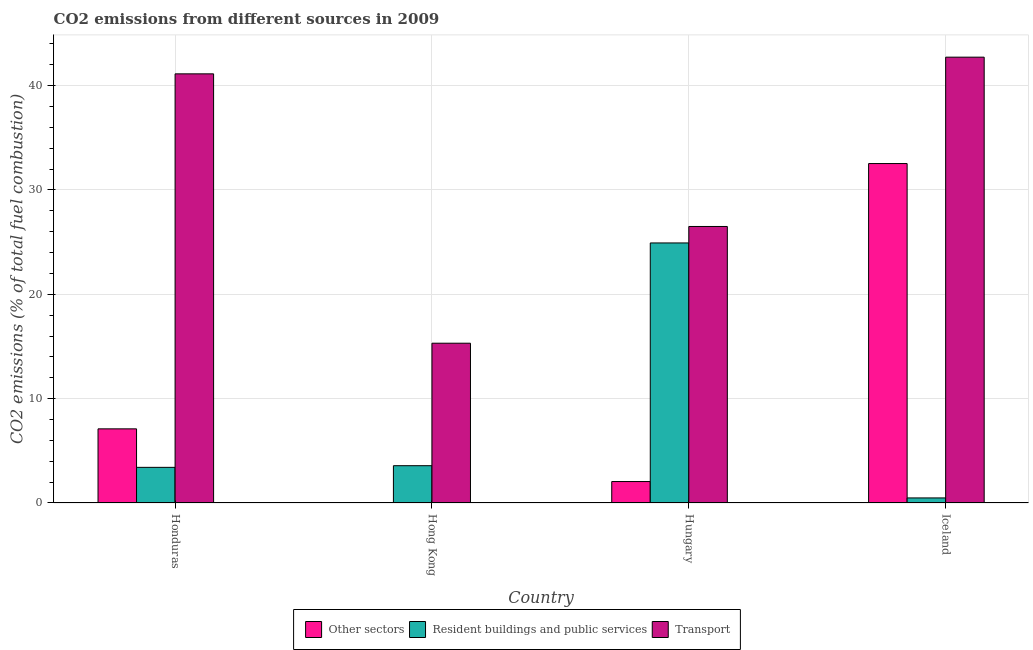How many groups of bars are there?
Make the answer very short. 4. What is the percentage of co2 emissions from resident buildings and public services in Hungary?
Your answer should be very brief. 24.92. Across all countries, what is the maximum percentage of co2 emissions from resident buildings and public services?
Your answer should be compact. 24.92. Across all countries, what is the minimum percentage of co2 emissions from resident buildings and public services?
Provide a succinct answer. 0.49. In which country was the percentage of co2 emissions from other sectors maximum?
Make the answer very short. Iceland. In which country was the percentage of co2 emissions from other sectors minimum?
Keep it short and to the point. Hong Kong. What is the total percentage of co2 emissions from transport in the graph?
Offer a very short reply. 125.64. What is the difference between the percentage of co2 emissions from other sectors in Hong Kong and that in Hungary?
Keep it short and to the point. -2.03. What is the difference between the percentage of co2 emissions from transport in Honduras and the percentage of co2 emissions from resident buildings and public services in Hong Kong?
Your answer should be compact. 37.55. What is the average percentage of co2 emissions from resident buildings and public services per country?
Your response must be concise. 8.1. What is the difference between the percentage of co2 emissions from other sectors and percentage of co2 emissions from resident buildings and public services in Honduras?
Your answer should be very brief. 3.69. What is the ratio of the percentage of co2 emissions from other sectors in Honduras to that in Hungary?
Your response must be concise. 3.46. What is the difference between the highest and the second highest percentage of co2 emissions from resident buildings and public services?
Give a very brief answer. 21.34. What is the difference between the highest and the lowest percentage of co2 emissions from resident buildings and public services?
Keep it short and to the point. 24.43. What does the 1st bar from the left in Honduras represents?
Give a very brief answer. Other sectors. What does the 1st bar from the right in Iceland represents?
Your response must be concise. Transport. How many bars are there?
Make the answer very short. 12. What is the difference between two consecutive major ticks on the Y-axis?
Give a very brief answer. 10. Where does the legend appear in the graph?
Your response must be concise. Bottom center. How are the legend labels stacked?
Give a very brief answer. Horizontal. What is the title of the graph?
Provide a short and direct response. CO2 emissions from different sources in 2009. What is the label or title of the Y-axis?
Your answer should be very brief. CO2 emissions (% of total fuel combustion). What is the CO2 emissions (% of total fuel combustion) in Other sectors in Honduras?
Provide a short and direct response. 7.1. What is the CO2 emissions (% of total fuel combustion) of Resident buildings and public services in Honduras?
Make the answer very short. 3.42. What is the CO2 emissions (% of total fuel combustion) of Transport in Honduras?
Provide a succinct answer. 41.12. What is the CO2 emissions (% of total fuel combustion) of Other sectors in Hong Kong?
Your answer should be very brief. 0.02. What is the CO2 emissions (% of total fuel combustion) in Resident buildings and public services in Hong Kong?
Your response must be concise. 3.57. What is the CO2 emissions (% of total fuel combustion) of Transport in Hong Kong?
Your answer should be compact. 15.31. What is the CO2 emissions (% of total fuel combustion) of Other sectors in Hungary?
Provide a short and direct response. 2.06. What is the CO2 emissions (% of total fuel combustion) in Resident buildings and public services in Hungary?
Your response must be concise. 24.92. What is the CO2 emissions (% of total fuel combustion) of Transport in Hungary?
Your answer should be compact. 26.5. What is the CO2 emissions (% of total fuel combustion) of Other sectors in Iceland?
Keep it short and to the point. 32.52. What is the CO2 emissions (% of total fuel combustion) of Resident buildings and public services in Iceland?
Offer a terse response. 0.49. What is the CO2 emissions (% of total fuel combustion) of Transport in Iceland?
Your answer should be very brief. 42.72. Across all countries, what is the maximum CO2 emissions (% of total fuel combustion) of Other sectors?
Provide a short and direct response. 32.52. Across all countries, what is the maximum CO2 emissions (% of total fuel combustion) of Resident buildings and public services?
Offer a terse response. 24.92. Across all countries, what is the maximum CO2 emissions (% of total fuel combustion) of Transport?
Your answer should be compact. 42.72. Across all countries, what is the minimum CO2 emissions (% of total fuel combustion) of Other sectors?
Keep it short and to the point. 0.02. Across all countries, what is the minimum CO2 emissions (% of total fuel combustion) in Resident buildings and public services?
Offer a very short reply. 0.49. Across all countries, what is the minimum CO2 emissions (% of total fuel combustion) of Transport?
Provide a succinct answer. 15.31. What is the total CO2 emissions (% of total fuel combustion) in Other sectors in the graph?
Make the answer very short. 41.71. What is the total CO2 emissions (% of total fuel combustion) of Resident buildings and public services in the graph?
Your answer should be compact. 32.39. What is the total CO2 emissions (% of total fuel combustion) of Transport in the graph?
Keep it short and to the point. 125.64. What is the difference between the CO2 emissions (% of total fuel combustion) of Other sectors in Honduras and that in Hong Kong?
Ensure brevity in your answer.  7.08. What is the difference between the CO2 emissions (% of total fuel combustion) of Resident buildings and public services in Honduras and that in Hong Kong?
Your answer should be very brief. -0.16. What is the difference between the CO2 emissions (% of total fuel combustion) in Transport in Honduras and that in Hong Kong?
Provide a succinct answer. 25.81. What is the difference between the CO2 emissions (% of total fuel combustion) in Other sectors in Honduras and that in Hungary?
Your response must be concise. 5.05. What is the difference between the CO2 emissions (% of total fuel combustion) in Resident buildings and public services in Honduras and that in Hungary?
Your response must be concise. -21.5. What is the difference between the CO2 emissions (% of total fuel combustion) in Transport in Honduras and that in Hungary?
Keep it short and to the point. 14.63. What is the difference between the CO2 emissions (% of total fuel combustion) in Other sectors in Honduras and that in Iceland?
Your answer should be compact. -25.42. What is the difference between the CO2 emissions (% of total fuel combustion) in Resident buildings and public services in Honduras and that in Iceland?
Offer a very short reply. 2.93. What is the difference between the CO2 emissions (% of total fuel combustion) of Transport in Honduras and that in Iceland?
Your answer should be compact. -1.6. What is the difference between the CO2 emissions (% of total fuel combustion) of Other sectors in Hong Kong and that in Hungary?
Provide a succinct answer. -2.03. What is the difference between the CO2 emissions (% of total fuel combustion) of Resident buildings and public services in Hong Kong and that in Hungary?
Your answer should be compact. -21.34. What is the difference between the CO2 emissions (% of total fuel combustion) in Transport in Hong Kong and that in Hungary?
Provide a succinct answer. -11.19. What is the difference between the CO2 emissions (% of total fuel combustion) of Other sectors in Hong Kong and that in Iceland?
Your response must be concise. -32.5. What is the difference between the CO2 emissions (% of total fuel combustion) in Resident buildings and public services in Hong Kong and that in Iceland?
Offer a very short reply. 3.09. What is the difference between the CO2 emissions (% of total fuel combustion) in Transport in Hong Kong and that in Iceland?
Make the answer very short. -27.41. What is the difference between the CO2 emissions (% of total fuel combustion) of Other sectors in Hungary and that in Iceland?
Your answer should be compact. -30.47. What is the difference between the CO2 emissions (% of total fuel combustion) in Resident buildings and public services in Hungary and that in Iceland?
Offer a terse response. 24.43. What is the difference between the CO2 emissions (% of total fuel combustion) of Transport in Hungary and that in Iceland?
Ensure brevity in your answer.  -16.22. What is the difference between the CO2 emissions (% of total fuel combustion) in Other sectors in Honduras and the CO2 emissions (% of total fuel combustion) in Resident buildings and public services in Hong Kong?
Provide a succinct answer. 3.53. What is the difference between the CO2 emissions (% of total fuel combustion) in Other sectors in Honduras and the CO2 emissions (% of total fuel combustion) in Transport in Hong Kong?
Keep it short and to the point. -8.21. What is the difference between the CO2 emissions (% of total fuel combustion) of Resident buildings and public services in Honduras and the CO2 emissions (% of total fuel combustion) of Transport in Hong Kong?
Offer a terse response. -11.89. What is the difference between the CO2 emissions (% of total fuel combustion) in Other sectors in Honduras and the CO2 emissions (% of total fuel combustion) in Resident buildings and public services in Hungary?
Your response must be concise. -17.81. What is the difference between the CO2 emissions (% of total fuel combustion) of Other sectors in Honduras and the CO2 emissions (% of total fuel combustion) of Transport in Hungary?
Make the answer very short. -19.39. What is the difference between the CO2 emissions (% of total fuel combustion) of Resident buildings and public services in Honduras and the CO2 emissions (% of total fuel combustion) of Transport in Hungary?
Your answer should be very brief. -23.08. What is the difference between the CO2 emissions (% of total fuel combustion) in Other sectors in Honduras and the CO2 emissions (% of total fuel combustion) in Resident buildings and public services in Iceland?
Provide a succinct answer. 6.62. What is the difference between the CO2 emissions (% of total fuel combustion) in Other sectors in Honduras and the CO2 emissions (% of total fuel combustion) in Transport in Iceland?
Offer a very short reply. -35.61. What is the difference between the CO2 emissions (% of total fuel combustion) in Resident buildings and public services in Honduras and the CO2 emissions (% of total fuel combustion) in Transport in Iceland?
Your answer should be compact. -39.3. What is the difference between the CO2 emissions (% of total fuel combustion) of Other sectors in Hong Kong and the CO2 emissions (% of total fuel combustion) of Resident buildings and public services in Hungary?
Ensure brevity in your answer.  -24.9. What is the difference between the CO2 emissions (% of total fuel combustion) in Other sectors in Hong Kong and the CO2 emissions (% of total fuel combustion) in Transport in Hungary?
Your answer should be compact. -26.47. What is the difference between the CO2 emissions (% of total fuel combustion) of Resident buildings and public services in Hong Kong and the CO2 emissions (% of total fuel combustion) of Transport in Hungary?
Offer a very short reply. -22.92. What is the difference between the CO2 emissions (% of total fuel combustion) of Other sectors in Hong Kong and the CO2 emissions (% of total fuel combustion) of Resident buildings and public services in Iceland?
Offer a very short reply. -0.46. What is the difference between the CO2 emissions (% of total fuel combustion) in Other sectors in Hong Kong and the CO2 emissions (% of total fuel combustion) in Transport in Iceland?
Your response must be concise. -42.7. What is the difference between the CO2 emissions (% of total fuel combustion) in Resident buildings and public services in Hong Kong and the CO2 emissions (% of total fuel combustion) in Transport in Iceland?
Your response must be concise. -39.15. What is the difference between the CO2 emissions (% of total fuel combustion) of Other sectors in Hungary and the CO2 emissions (% of total fuel combustion) of Resident buildings and public services in Iceland?
Offer a very short reply. 1.57. What is the difference between the CO2 emissions (% of total fuel combustion) in Other sectors in Hungary and the CO2 emissions (% of total fuel combustion) in Transport in Iceland?
Offer a terse response. -40.66. What is the difference between the CO2 emissions (% of total fuel combustion) of Resident buildings and public services in Hungary and the CO2 emissions (% of total fuel combustion) of Transport in Iceland?
Give a very brief answer. -17.8. What is the average CO2 emissions (% of total fuel combustion) in Other sectors per country?
Your response must be concise. 10.43. What is the average CO2 emissions (% of total fuel combustion) in Resident buildings and public services per country?
Make the answer very short. 8.1. What is the average CO2 emissions (% of total fuel combustion) in Transport per country?
Provide a succinct answer. 31.41. What is the difference between the CO2 emissions (% of total fuel combustion) in Other sectors and CO2 emissions (% of total fuel combustion) in Resident buildings and public services in Honduras?
Your answer should be compact. 3.69. What is the difference between the CO2 emissions (% of total fuel combustion) in Other sectors and CO2 emissions (% of total fuel combustion) in Transport in Honduras?
Offer a terse response. -34.02. What is the difference between the CO2 emissions (% of total fuel combustion) in Resident buildings and public services and CO2 emissions (% of total fuel combustion) in Transport in Honduras?
Your answer should be very brief. -37.7. What is the difference between the CO2 emissions (% of total fuel combustion) of Other sectors and CO2 emissions (% of total fuel combustion) of Resident buildings and public services in Hong Kong?
Offer a very short reply. -3.55. What is the difference between the CO2 emissions (% of total fuel combustion) in Other sectors and CO2 emissions (% of total fuel combustion) in Transport in Hong Kong?
Your response must be concise. -15.29. What is the difference between the CO2 emissions (% of total fuel combustion) of Resident buildings and public services and CO2 emissions (% of total fuel combustion) of Transport in Hong Kong?
Offer a terse response. -11.74. What is the difference between the CO2 emissions (% of total fuel combustion) of Other sectors and CO2 emissions (% of total fuel combustion) of Resident buildings and public services in Hungary?
Ensure brevity in your answer.  -22.86. What is the difference between the CO2 emissions (% of total fuel combustion) in Other sectors and CO2 emissions (% of total fuel combustion) in Transport in Hungary?
Keep it short and to the point. -24.44. What is the difference between the CO2 emissions (% of total fuel combustion) of Resident buildings and public services and CO2 emissions (% of total fuel combustion) of Transport in Hungary?
Give a very brief answer. -1.58. What is the difference between the CO2 emissions (% of total fuel combustion) in Other sectors and CO2 emissions (% of total fuel combustion) in Resident buildings and public services in Iceland?
Ensure brevity in your answer.  32.04. What is the difference between the CO2 emissions (% of total fuel combustion) of Other sectors and CO2 emissions (% of total fuel combustion) of Transport in Iceland?
Give a very brief answer. -10.19. What is the difference between the CO2 emissions (% of total fuel combustion) of Resident buildings and public services and CO2 emissions (% of total fuel combustion) of Transport in Iceland?
Provide a succinct answer. -42.23. What is the ratio of the CO2 emissions (% of total fuel combustion) of Other sectors in Honduras to that in Hong Kong?
Give a very brief answer. 328.05. What is the ratio of the CO2 emissions (% of total fuel combustion) in Resident buildings and public services in Honduras to that in Hong Kong?
Your answer should be compact. 0.96. What is the ratio of the CO2 emissions (% of total fuel combustion) in Transport in Honduras to that in Hong Kong?
Give a very brief answer. 2.69. What is the ratio of the CO2 emissions (% of total fuel combustion) of Other sectors in Honduras to that in Hungary?
Your answer should be compact. 3.46. What is the ratio of the CO2 emissions (% of total fuel combustion) in Resident buildings and public services in Honduras to that in Hungary?
Offer a very short reply. 0.14. What is the ratio of the CO2 emissions (% of total fuel combustion) of Transport in Honduras to that in Hungary?
Provide a succinct answer. 1.55. What is the ratio of the CO2 emissions (% of total fuel combustion) of Other sectors in Honduras to that in Iceland?
Your response must be concise. 0.22. What is the ratio of the CO2 emissions (% of total fuel combustion) of Resident buildings and public services in Honduras to that in Iceland?
Your response must be concise. 7.04. What is the ratio of the CO2 emissions (% of total fuel combustion) of Transport in Honduras to that in Iceland?
Keep it short and to the point. 0.96. What is the ratio of the CO2 emissions (% of total fuel combustion) of Other sectors in Hong Kong to that in Hungary?
Provide a short and direct response. 0.01. What is the ratio of the CO2 emissions (% of total fuel combustion) of Resident buildings and public services in Hong Kong to that in Hungary?
Provide a succinct answer. 0.14. What is the ratio of the CO2 emissions (% of total fuel combustion) of Transport in Hong Kong to that in Hungary?
Ensure brevity in your answer.  0.58. What is the ratio of the CO2 emissions (% of total fuel combustion) in Other sectors in Hong Kong to that in Iceland?
Offer a very short reply. 0. What is the ratio of the CO2 emissions (% of total fuel combustion) in Resident buildings and public services in Hong Kong to that in Iceland?
Your response must be concise. 7.36. What is the ratio of the CO2 emissions (% of total fuel combustion) of Transport in Hong Kong to that in Iceland?
Your answer should be compact. 0.36. What is the ratio of the CO2 emissions (% of total fuel combustion) in Other sectors in Hungary to that in Iceland?
Your answer should be very brief. 0.06. What is the ratio of the CO2 emissions (% of total fuel combustion) of Resident buildings and public services in Hungary to that in Iceland?
Your answer should be compact. 51.33. What is the ratio of the CO2 emissions (% of total fuel combustion) of Transport in Hungary to that in Iceland?
Your answer should be very brief. 0.62. What is the difference between the highest and the second highest CO2 emissions (% of total fuel combustion) in Other sectors?
Keep it short and to the point. 25.42. What is the difference between the highest and the second highest CO2 emissions (% of total fuel combustion) of Resident buildings and public services?
Make the answer very short. 21.34. What is the difference between the highest and the second highest CO2 emissions (% of total fuel combustion) of Transport?
Your response must be concise. 1.6. What is the difference between the highest and the lowest CO2 emissions (% of total fuel combustion) in Other sectors?
Provide a succinct answer. 32.5. What is the difference between the highest and the lowest CO2 emissions (% of total fuel combustion) of Resident buildings and public services?
Make the answer very short. 24.43. What is the difference between the highest and the lowest CO2 emissions (% of total fuel combustion) in Transport?
Ensure brevity in your answer.  27.41. 